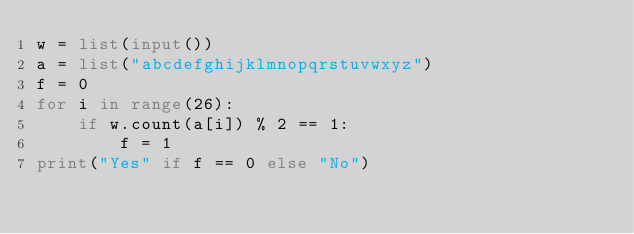<code> <loc_0><loc_0><loc_500><loc_500><_Python_>w = list(input())
a = list("abcdefghijklmnopqrstuvwxyz")
f = 0
for i in range(26):
    if w.count(a[i]) % 2 == 1:
        f = 1
print("Yes" if f == 0 else "No")</code> 